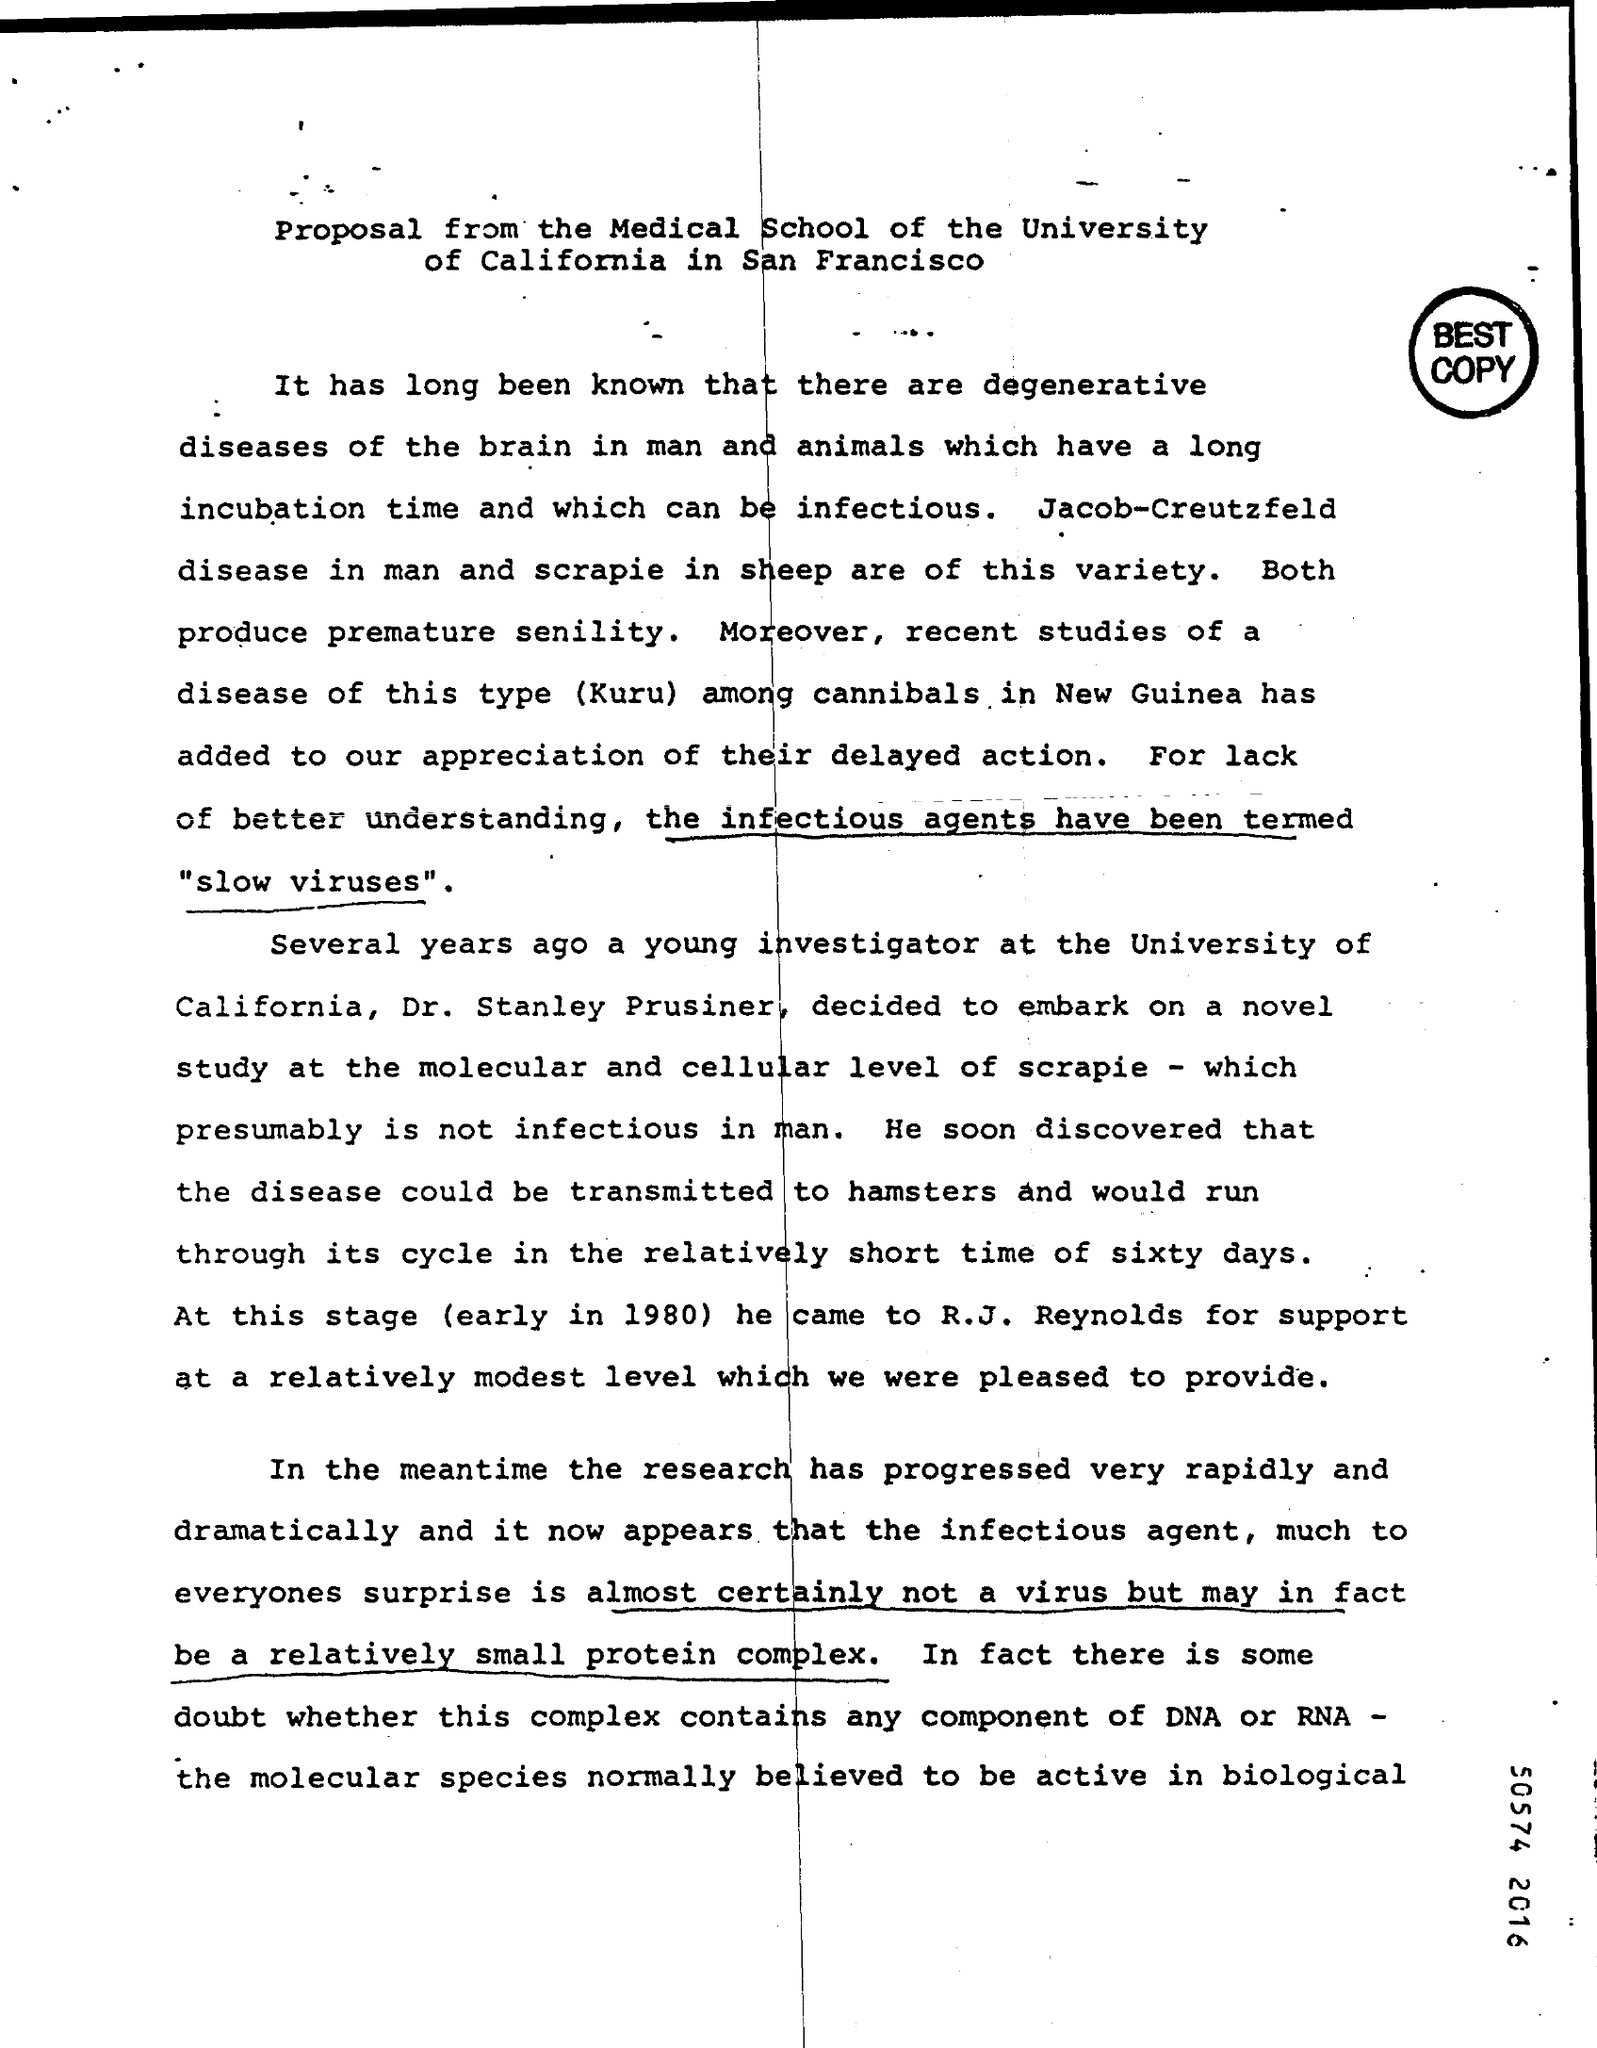Give some essential details in this illustration. A relatively small protein complex is the current known infectious agent. According to the information provided, the time of life cycle when the disease is transmitted to hamsters is sixty days. Kuru is a disease that is carried out among cannibals and is a type of study. 